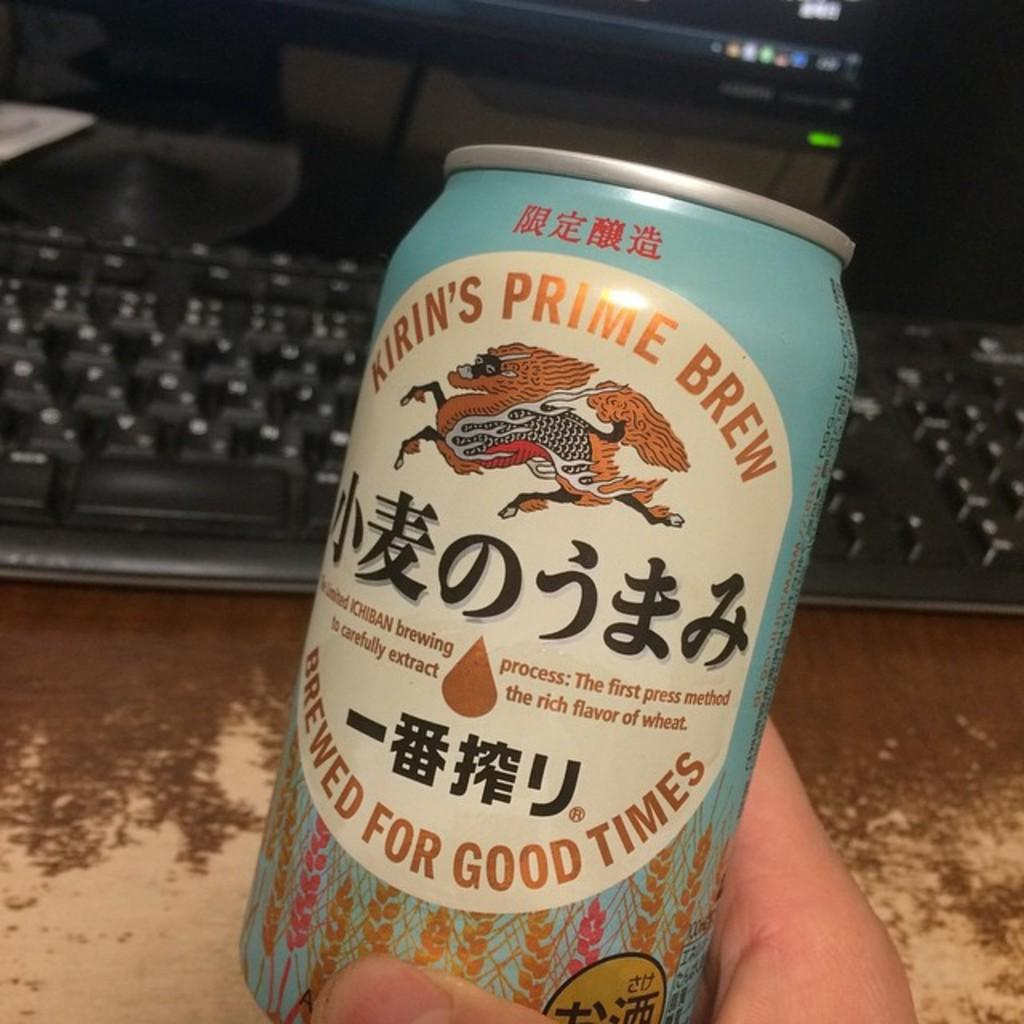<image>
Create a compact narrative representing the image presented. A person holds a can of Kirin's Prime Brew in front of a computer keyboard. 